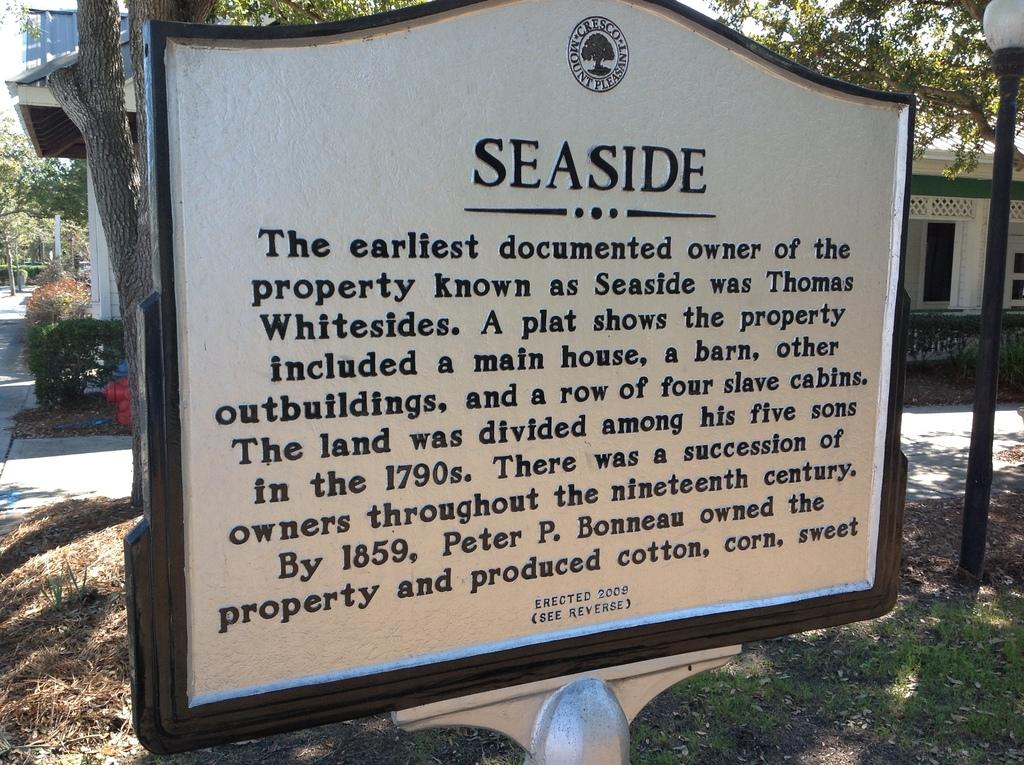What is written or displayed on the board in the image? There is a board with text in the image. What can be seen in the background of the image? There are trees, plants, and a house in the background of the image. Where is the light pole located in the image? The light pole is on the right side of the image. What year is depicted on the board in the image? There is no year displayed on the board in the image. What type of neck accessory is worn by the trees in the background? Trees do not wear neck accessories; they are natural objects in the image. 